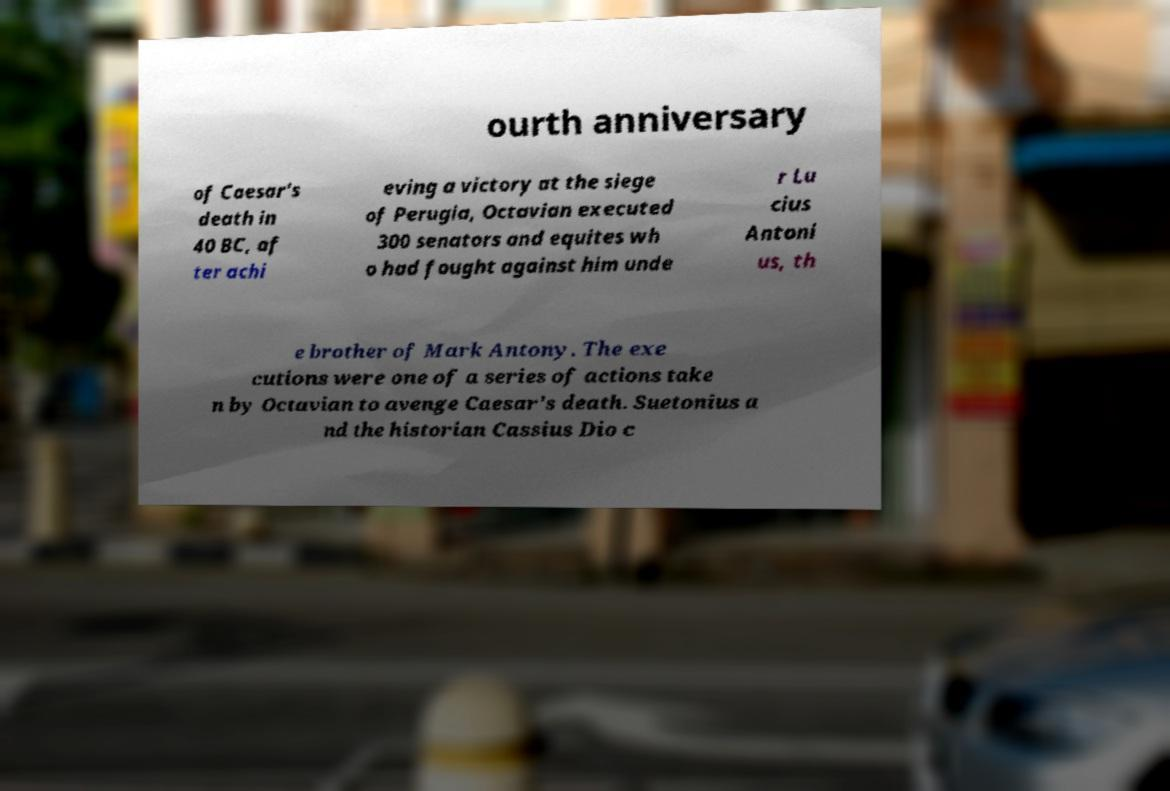Please identify and transcribe the text found in this image. ourth anniversary of Caesar's death in 40 BC, af ter achi eving a victory at the siege of Perugia, Octavian executed 300 senators and equites wh o had fought against him unde r Lu cius Antoni us, th e brother of Mark Antony. The exe cutions were one of a series of actions take n by Octavian to avenge Caesar's death. Suetonius a nd the historian Cassius Dio c 